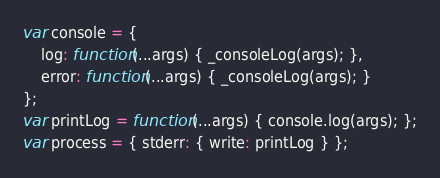<code> <loc_0><loc_0><loc_500><loc_500><_JavaScript_>var console = {
    log: function(...args) { _consoleLog(args); },
    error: function(...args) { _consoleLog(args); }
};
var printLog = function(...args) { console.log(args); };
var process = { stderr: { write: printLog } };
</code> 